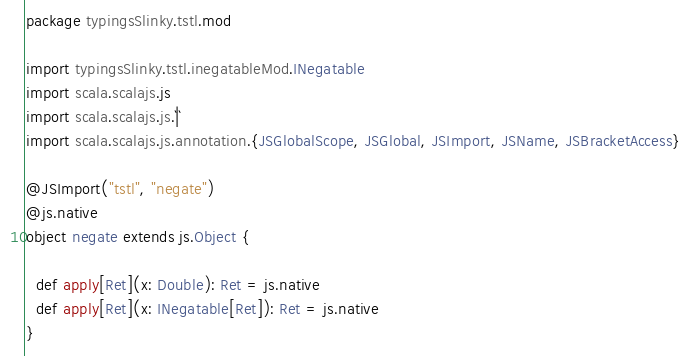<code> <loc_0><loc_0><loc_500><loc_500><_Scala_>package typingsSlinky.tstl.mod

import typingsSlinky.tstl.inegatableMod.INegatable
import scala.scalajs.js
import scala.scalajs.js.`|`
import scala.scalajs.js.annotation.{JSGlobalScope, JSGlobal, JSImport, JSName, JSBracketAccess}

@JSImport("tstl", "negate")
@js.native
object negate extends js.Object {
  
  def apply[Ret](x: Double): Ret = js.native
  def apply[Ret](x: INegatable[Ret]): Ret = js.native
}
</code> 